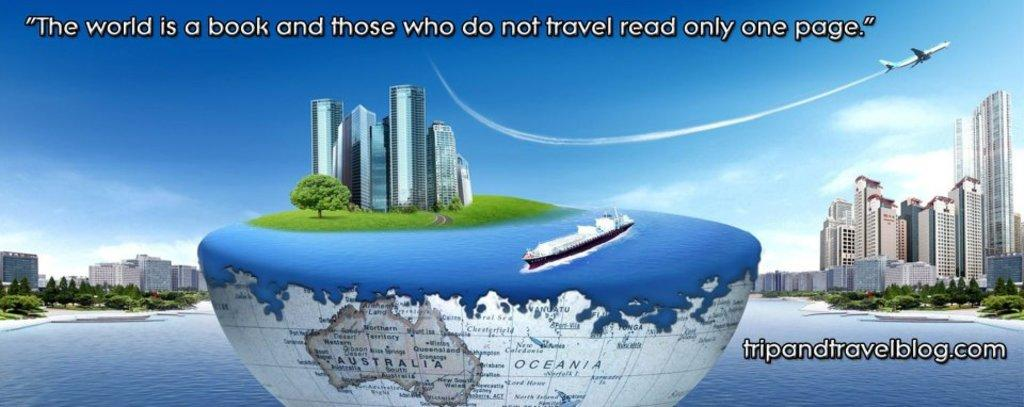<image>
Write a terse but informative summary of the picture. A colorful advertisement for a travel blog website. 